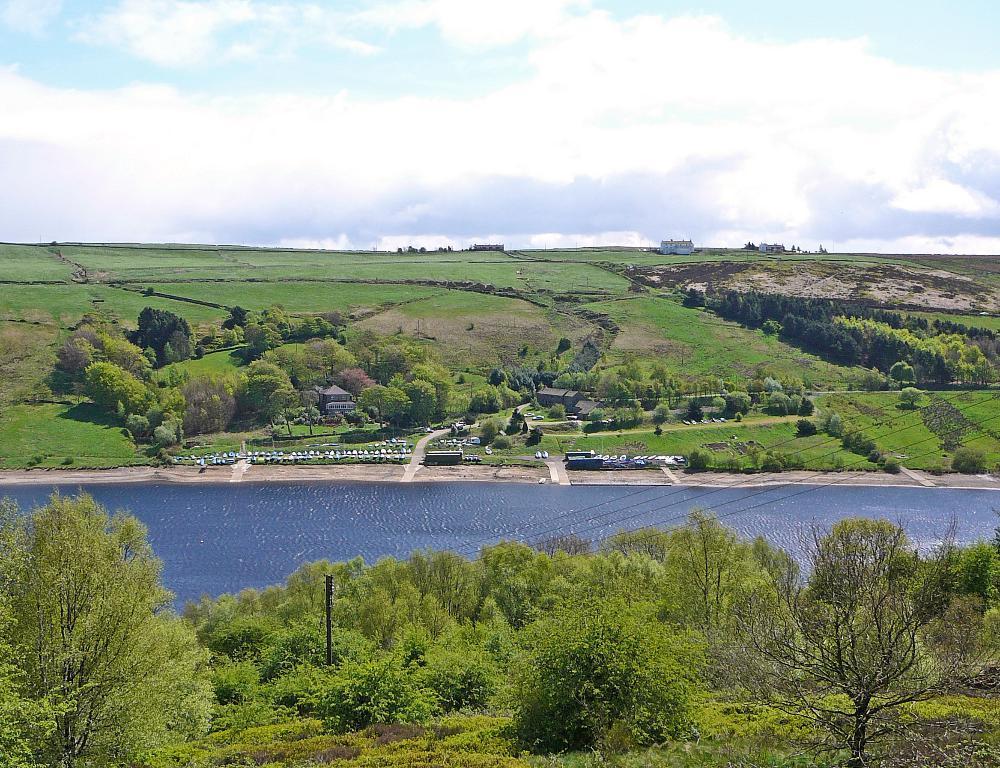Can you describe this image briefly? This image is taken outdoors. At the bottom of the image there is a ground with grass and many plants and trees on it. In the middle of the image there is a river with water. In the background there is a ground with a few trees, plants and houses. At the top of the image there is a sky with clouds. 